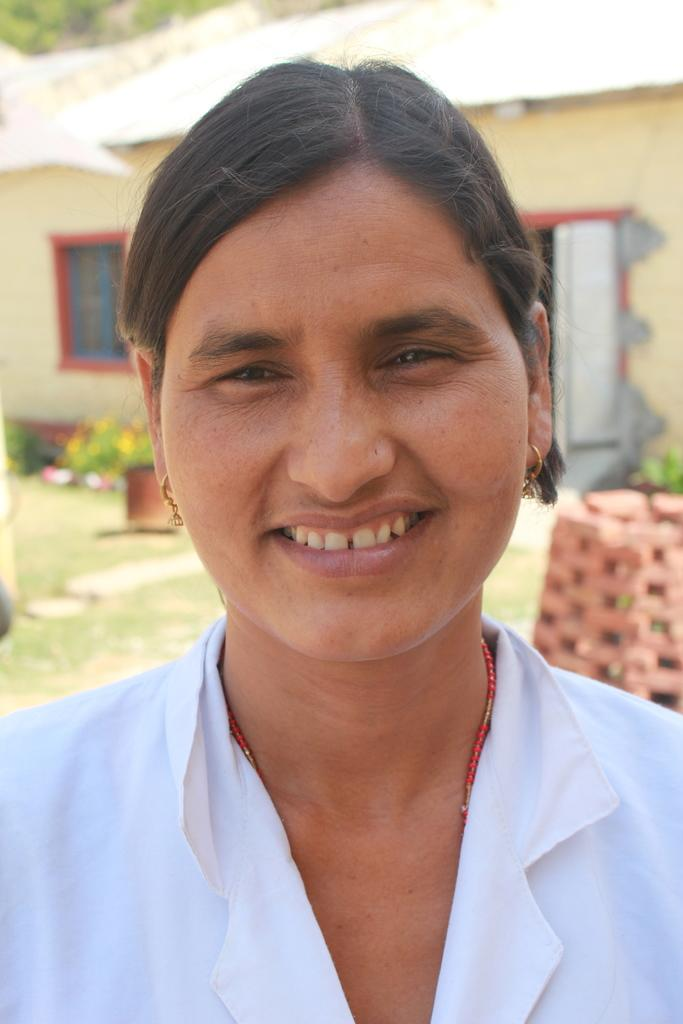Who is present in the image? There is a woman in the image. What is the woman doing in the image? The woman is smiling in the image. What can be seen in the background of the image? There is a house behind the woman in the image. What type of horn can be heard in the image? There is no horn present in the image, and therefore no sound can be heard. What agreement was reached between the woman and the house in the image? There is no indication of any agreement in the image, as it only shows a woman smiling and a house in the background. 